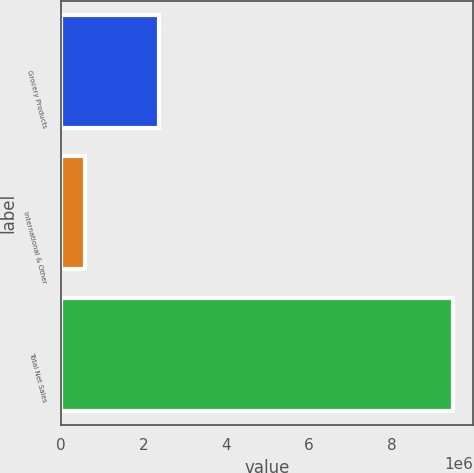Convert chart. <chart><loc_0><loc_0><loc_500><loc_500><bar_chart><fcel>Grocery Products<fcel>International & Other<fcel>Total Net Sales<nl><fcel>2.36932e+06<fcel>593476<fcel>9.49732e+06<nl></chart> 